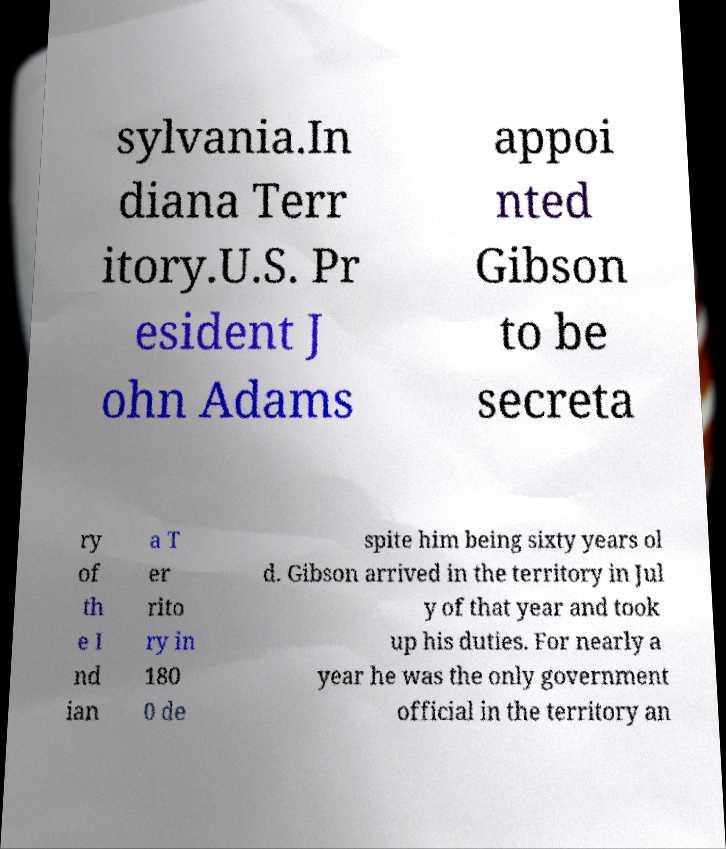Please identify and transcribe the text found in this image. sylvania.In diana Terr itory.U.S. Pr esident J ohn Adams appoi nted Gibson to be secreta ry of th e I nd ian a T er rito ry in 180 0 de spite him being sixty years ol d. Gibson arrived in the territory in Jul y of that year and took up his duties. For nearly a year he was the only government official in the territory an 